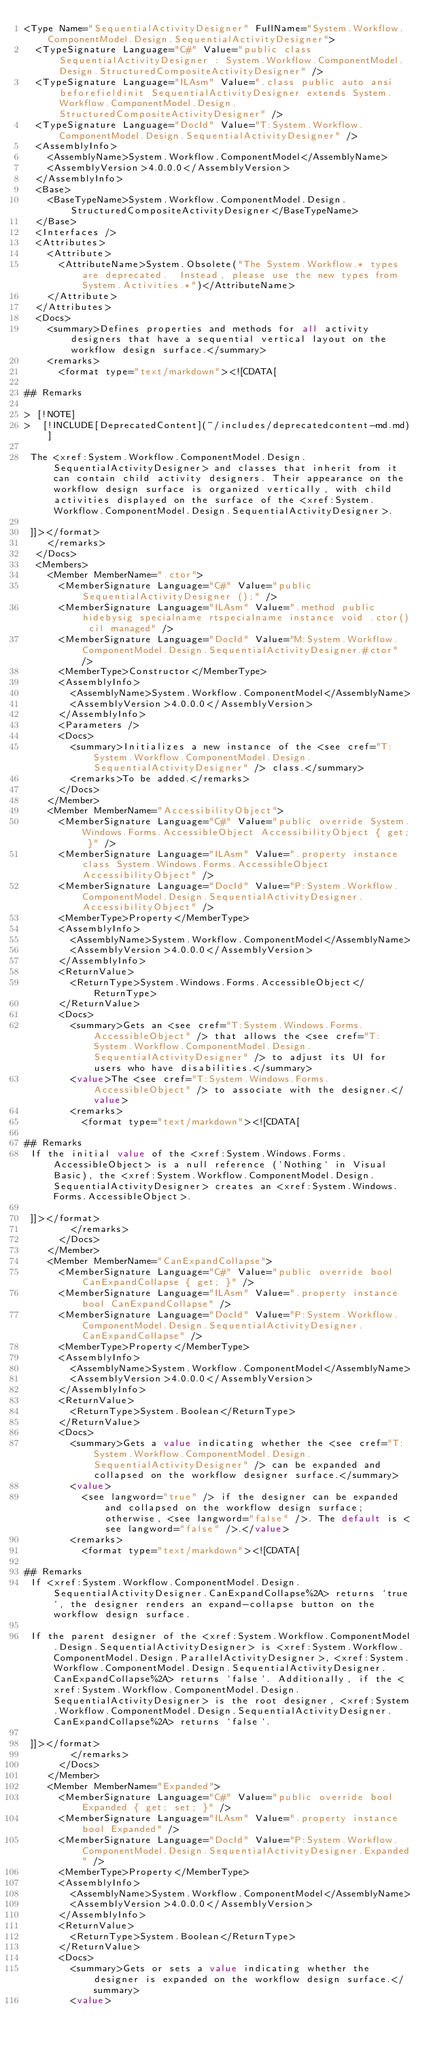<code> <loc_0><loc_0><loc_500><loc_500><_XML_><Type Name="SequentialActivityDesigner" FullName="System.Workflow.ComponentModel.Design.SequentialActivityDesigner">
  <TypeSignature Language="C#" Value="public class SequentialActivityDesigner : System.Workflow.ComponentModel.Design.StructuredCompositeActivityDesigner" />
  <TypeSignature Language="ILAsm" Value=".class public auto ansi beforefieldinit SequentialActivityDesigner extends System.Workflow.ComponentModel.Design.StructuredCompositeActivityDesigner" />
  <TypeSignature Language="DocId" Value="T:System.Workflow.ComponentModel.Design.SequentialActivityDesigner" />
  <AssemblyInfo>
    <AssemblyName>System.Workflow.ComponentModel</AssemblyName>
    <AssemblyVersion>4.0.0.0</AssemblyVersion>
  </AssemblyInfo>
  <Base>
    <BaseTypeName>System.Workflow.ComponentModel.Design.StructuredCompositeActivityDesigner</BaseTypeName>
  </Base>
  <Interfaces />
  <Attributes>
    <Attribute>
      <AttributeName>System.Obsolete("The System.Workflow.* types are deprecated.  Instead, please use the new types from System.Activities.*")</AttributeName>
    </Attribute>
  </Attributes>
  <Docs>
    <summary>Defines properties and methods for all activity designers that have a sequential vertical layout on the workflow design surface.</summary>
    <remarks>
      <format type="text/markdown"><![CDATA[  
  
## Remarks  
  
> [!NOTE]
>  [!INCLUDE[DeprecatedContent](~/includes/deprecatedcontent-md.md)]  
  
 The <xref:System.Workflow.ComponentModel.Design.SequentialActivityDesigner> and classes that inherit from it can contain child activity designers. Their appearance on the workflow design surface is organized vertically, with child activities displayed on the surface of the <xref:System.Workflow.ComponentModel.Design.SequentialActivityDesigner>.  
  
 ]]></format>
    </remarks>
  </Docs>
  <Members>
    <Member MemberName=".ctor">
      <MemberSignature Language="C#" Value="public SequentialActivityDesigner ();" />
      <MemberSignature Language="ILAsm" Value=".method public hidebysig specialname rtspecialname instance void .ctor() cil managed" />
      <MemberSignature Language="DocId" Value="M:System.Workflow.ComponentModel.Design.SequentialActivityDesigner.#ctor" />
      <MemberType>Constructor</MemberType>
      <AssemblyInfo>
        <AssemblyName>System.Workflow.ComponentModel</AssemblyName>
        <AssemblyVersion>4.0.0.0</AssemblyVersion>
      </AssemblyInfo>
      <Parameters />
      <Docs>
        <summary>Initializes a new instance of the <see cref="T:System.Workflow.ComponentModel.Design.SequentialActivityDesigner" /> class.</summary>
        <remarks>To be added.</remarks>
      </Docs>
    </Member>
    <Member MemberName="AccessibilityObject">
      <MemberSignature Language="C#" Value="public override System.Windows.Forms.AccessibleObject AccessibilityObject { get; }" />
      <MemberSignature Language="ILAsm" Value=".property instance class System.Windows.Forms.AccessibleObject AccessibilityObject" />
      <MemberSignature Language="DocId" Value="P:System.Workflow.ComponentModel.Design.SequentialActivityDesigner.AccessibilityObject" />
      <MemberType>Property</MemberType>
      <AssemblyInfo>
        <AssemblyName>System.Workflow.ComponentModel</AssemblyName>
        <AssemblyVersion>4.0.0.0</AssemblyVersion>
      </AssemblyInfo>
      <ReturnValue>
        <ReturnType>System.Windows.Forms.AccessibleObject</ReturnType>
      </ReturnValue>
      <Docs>
        <summary>Gets an <see cref="T:System.Windows.Forms.AccessibleObject" /> that allows the <see cref="T:System.Workflow.ComponentModel.Design.SequentialActivityDesigner" /> to adjust its UI for users who have disabilities.</summary>
        <value>The <see cref="T:System.Windows.Forms.AccessibleObject" /> to associate with the designer.</value>
        <remarks>
          <format type="text/markdown"><![CDATA[  
  
## Remarks  
 If the initial value of the <xref:System.Windows.Forms.AccessibleObject> is a null reference (`Nothing` in Visual Basic), the <xref:System.Workflow.ComponentModel.Design.SequentialActivityDesigner> creates an <xref:System.Windows.Forms.AccessibleObject>.  
  
 ]]></format>
        </remarks>
      </Docs>
    </Member>
    <Member MemberName="CanExpandCollapse">
      <MemberSignature Language="C#" Value="public override bool CanExpandCollapse { get; }" />
      <MemberSignature Language="ILAsm" Value=".property instance bool CanExpandCollapse" />
      <MemberSignature Language="DocId" Value="P:System.Workflow.ComponentModel.Design.SequentialActivityDesigner.CanExpandCollapse" />
      <MemberType>Property</MemberType>
      <AssemblyInfo>
        <AssemblyName>System.Workflow.ComponentModel</AssemblyName>
        <AssemblyVersion>4.0.0.0</AssemblyVersion>
      </AssemblyInfo>
      <ReturnValue>
        <ReturnType>System.Boolean</ReturnType>
      </ReturnValue>
      <Docs>
        <summary>Gets a value indicating whether the <see cref="T:System.Workflow.ComponentModel.Design.SequentialActivityDesigner" /> can be expanded and collapsed on the workflow designer surface.</summary>
        <value>
          <see langword="true" /> if the designer can be expanded and collapsed on the workflow design surface; otherwise, <see langword="false" />. The default is <see langword="false" />.</value>
        <remarks>
          <format type="text/markdown"><![CDATA[  
  
## Remarks  
 If <xref:System.Workflow.ComponentModel.Design.SequentialActivityDesigner.CanExpandCollapse%2A> returns `true`, the designer renders an expand-collapse button on the workflow design surface.  
  
 If the parent designer of the <xref:System.Workflow.ComponentModel.Design.SequentialActivityDesigner> is <xref:System.Workflow.ComponentModel.Design.ParallelActivityDesigner>, <xref:System.Workflow.ComponentModel.Design.SequentialActivityDesigner.CanExpandCollapse%2A> returns `false`. Additionally, if the <xref:System.Workflow.ComponentModel.Design.SequentialActivityDesigner> is the root designer, <xref:System.Workflow.ComponentModel.Design.SequentialActivityDesigner.CanExpandCollapse%2A> returns `false`.  
  
 ]]></format>
        </remarks>
      </Docs>
    </Member>
    <Member MemberName="Expanded">
      <MemberSignature Language="C#" Value="public override bool Expanded { get; set; }" />
      <MemberSignature Language="ILAsm" Value=".property instance bool Expanded" />
      <MemberSignature Language="DocId" Value="P:System.Workflow.ComponentModel.Design.SequentialActivityDesigner.Expanded" />
      <MemberType>Property</MemberType>
      <AssemblyInfo>
        <AssemblyName>System.Workflow.ComponentModel</AssemblyName>
        <AssemblyVersion>4.0.0.0</AssemblyVersion>
      </AssemblyInfo>
      <ReturnValue>
        <ReturnType>System.Boolean</ReturnType>
      </ReturnValue>
      <Docs>
        <summary>Gets or sets a value indicating whether the designer is expanded on the workflow design surface.</summary>
        <value></code> 